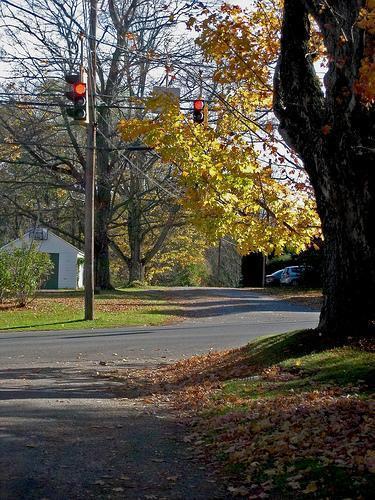How many lights are there?
Give a very brief answer. 2. 